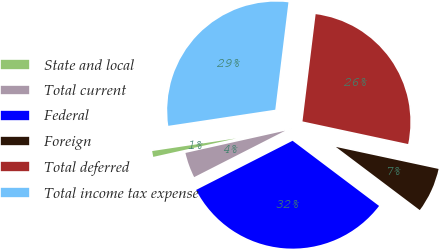<chart> <loc_0><loc_0><loc_500><loc_500><pie_chart><fcel>State and local<fcel>Total current<fcel>Federal<fcel>Foreign<fcel>Total deferred<fcel>Total income tax expense<nl><fcel>1.11%<fcel>4.01%<fcel>32.22%<fcel>6.91%<fcel>26.42%<fcel>29.32%<nl></chart> 